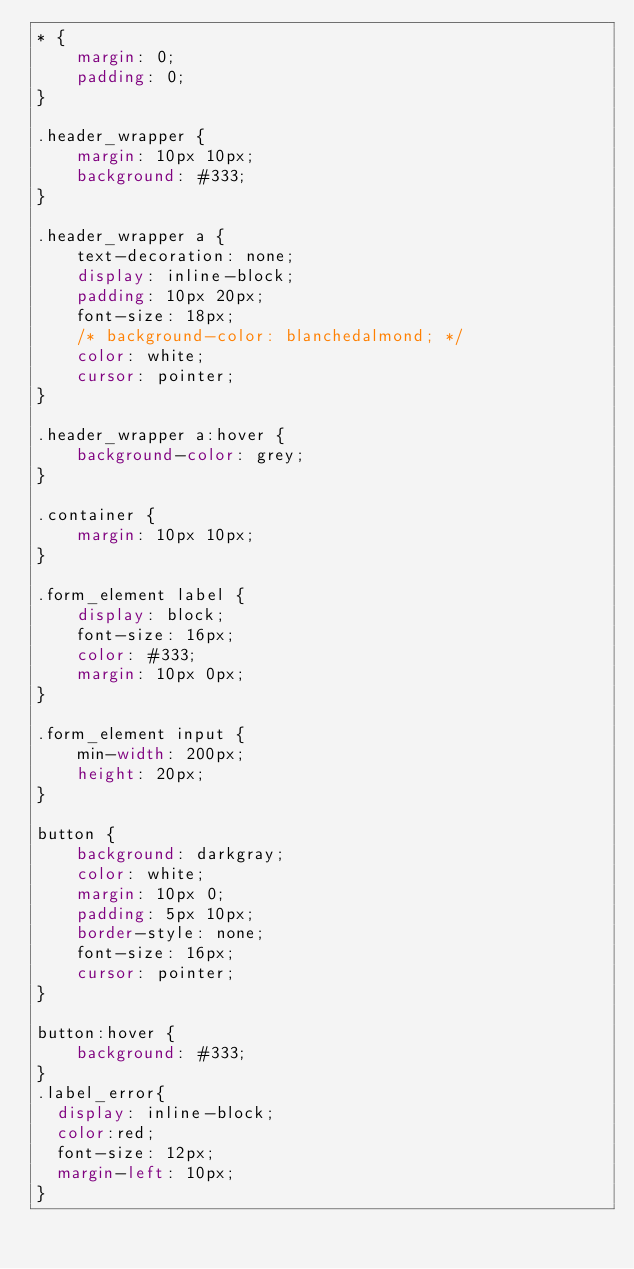Convert code to text. <code><loc_0><loc_0><loc_500><loc_500><_CSS_>* {
    margin: 0;
    padding: 0;
}

.header_wrapper {
    margin: 10px 10px;
    background: #333;
}

.header_wrapper a {
    text-decoration: none;
    display: inline-block;
    padding: 10px 20px;
    font-size: 18px;
    /* background-color: blanchedalmond; */
    color: white;
    cursor: pointer;
}

.header_wrapper a:hover {
    background-color: grey;
}

.container {
    margin: 10px 10px;
}

.form_element label {
    display: block;
    font-size: 16px;
    color: #333;
    margin: 10px 0px;
}

.form_element input {
    min-width: 200px;
    height: 20px;
}

button {
    background: darkgray;
    color: white;
    margin: 10px 0;
    padding: 5px 10px;
    border-style: none;
    font-size: 16px;
    cursor: pointer;
}

button:hover {
    background: #333;
}
.label_error{
  display: inline-block;
  color:red;
  font-size: 12px;
  margin-left: 10px;
}</code> 